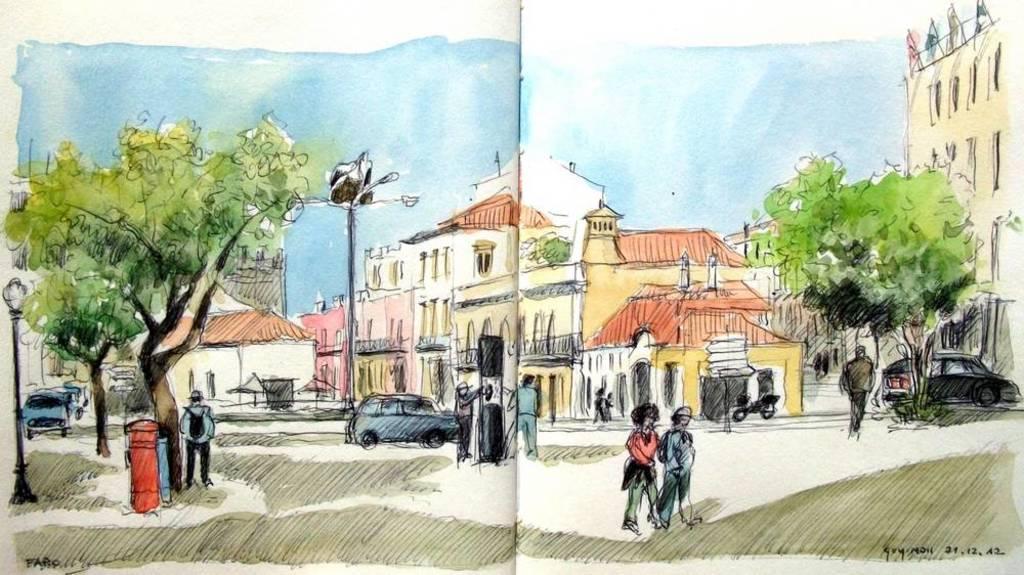Could you give a brief overview of what you see in this image? In the image inside the book there is painting. In the painting there are few people, poles with lamps, trees, bins, vehicles and also there are buildings. In the bottom right corner of the image there is text. 